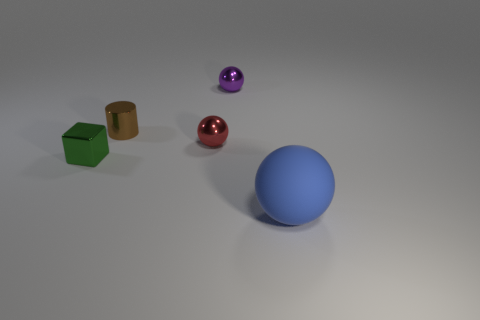Subtract all small spheres. How many spheres are left? 1 Subtract 1 cubes. How many cubes are left? 0 Add 4 yellow rubber cubes. How many objects exist? 9 Subtract all blue balls. How many balls are left? 2 Subtract all blocks. How many objects are left? 4 Subtract all cyan balls. Subtract all green cylinders. How many balls are left? 3 Subtract all yellow cubes. How many purple balls are left? 1 Subtract all metallic balls. Subtract all small metal cylinders. How many objects are left? 2 Add 4 big objects. How many big objects are left? 5 Add 3 tiny green metallic cubes. How many tiny green metallic cubes exist? 4 